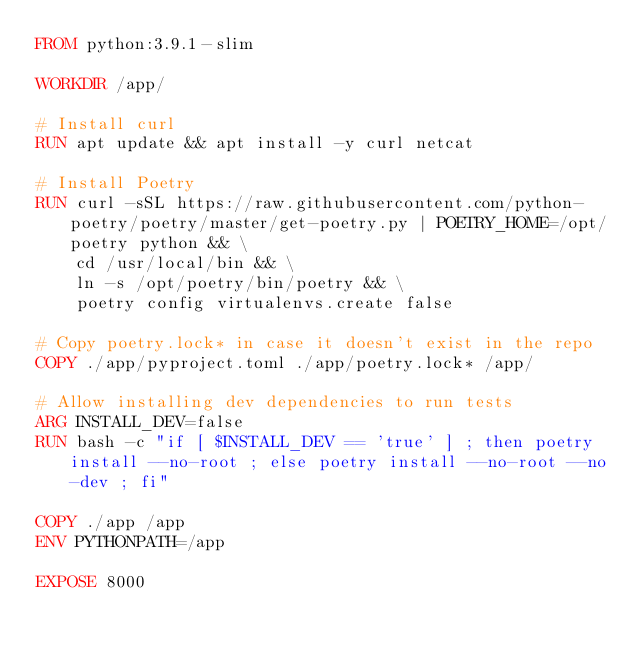Convert code to text. <code><loc_0><loc_0><loc_500><loc_500><_Dockerfile_>FROM python:3.9.1-slim

WORKDIR /app/

# Install curl
RUN apt update && apt install -y curl netcat

# Install Poetry
RUN curl -sSL https://raw.githubusercontent.com/python-poetry/poetry/master/get-poetry.py | POETRY_HOME=/opt/poetry python && \
    cd /usr/local/bin && \
    ln -s /opt/poetry/bin/poetry && \
    poetry config virtualenvs.create false

# Copy poetry.lock* in case it doesn't exist in the repo
COPY ./app/pyproject.toml ./app/poetry.lock* /app/

# Allow installing dev dependencies to run tests
ARG INSTALL_DEV=false
RUN bash -c "if [ $INSTALL_DEV == 'true' ] ; then poetry install --no-root ; else poetry install --no-root --no-dev ; fi"

COPY ./app /app
ENV PYTHONPATH=/app

EXPOSE 8000</code> 